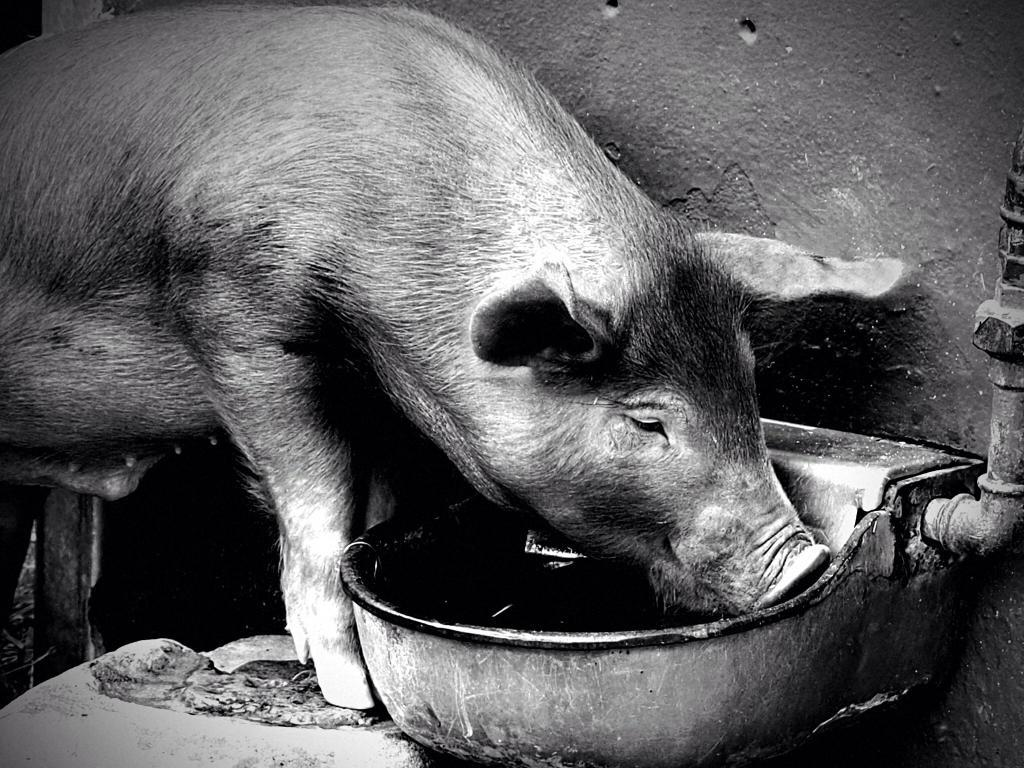What is the color scheme of the image? The image is black and white. What animal can be seen in the image? There is a pig in the image. What is the pig doing in the image? The pig's mouth is in a bowl. How many trees can be seen in the image? There are no trees visible in the image, as it is a black and white image featuring a pig with its mouth in a bowl. What type of mask is the pig wearing in the image? There is no mask present in the image; the pig's mouth is simply in a bowl. 